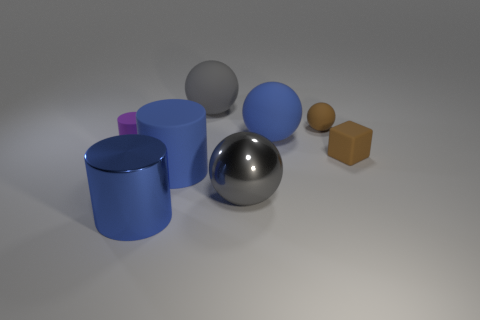How many small gray rubber things are there?
Provide a short and direct response. 0. There is a big cylinder left of the big blue rubber thing that is left of the gray object that is in front of the rubber cube; what is its color?
Offer a terse response. Blue. Is the number of tiny yellow matte things less than the number of purple cylinders?
Your answer should be compact. Yes. What is the color of the other shiny object that is the same shape as the tiny purple object?
Make the answer very short. Blue. The other large cylinder that is the same material as the purple cylinder is what color?
Your answer should be compact. Blue. What number of objects are the same size as the blue metal cylinder?
Ensure brevity in your answer.  4. What material is the purple thing?
Give a very brief answer. Rubber. Is the number of red objects greater than the number of tiny purple matte cylinders?
Give a very brief answer. No. Is the shape of the purple object the same as the large gray rubber thing?
Make the answer very short. No. Is there any other thing that has the same shape as the purple object?
Your answer should be very brief. Yes. 